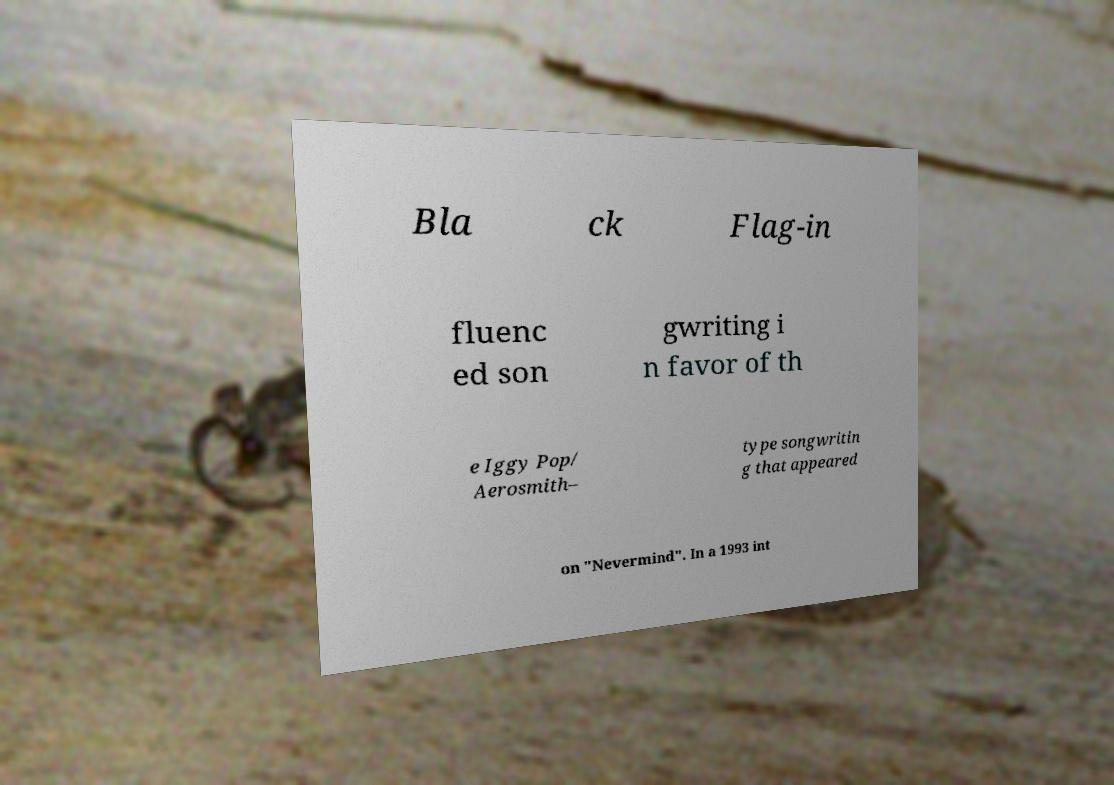Please read and relay the text visible in this image. What does it say? Bla ck Flag-in fluenc ed son gwriting i n favor of th e Iggy Pop/ Aerosmith– type songwritin g that appeared on "Nevermind". In a 1993 int 